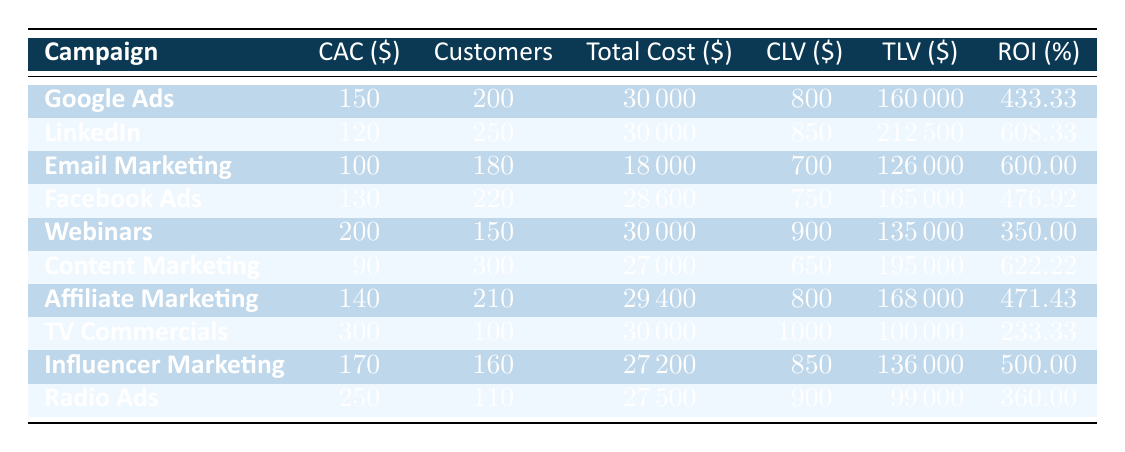What is the Cost of Customer Acquisition (CAC) for Email Marketing? The table shows that the CAC for the Email Marketing campaign is listed under the "CAC ($)" column. Looking at the row for Email Marketing, the value provided is 100.
Answer: 100 Which marketing campaign had the highest total lifetime value (TLV)? Upon examining the "TLV ($)" column, the highest value is found by comparing all campaigns. The LinkedIn Sponsored Content campaign has a TLV of 212,500, which is greater than all other campaigns.
Answer: LinkedIn Sponsored Content What is the average return on investment (ROI) across all marketing campaigns? To find the average ROI, I need to sum all the ROI percentages from each campaign and divide by the number of campaigns. The ROIs are 433.33, 608.33, 600.00, 476.92, 350.00, 622.22, 471.43, 233.33, 500.00, and 360.00. Summing these gives 4162.63, and dividing by 10 yields an average ROI of about 416.26.
Answer: 416.26 Did the Webinars campaign produce more customers than TV Commercials? Looking at the "Customers" column, Webinars acquired 150 customers while TV Commercials only acquired 100 customers. Therefore, Webinars did indeed produce more customers than TV Commercials.
Answer: Yes If the Content Marketing campaign had an additional cost of 5,000, would its new ROI still be greater than 600? The total cost for Content Marketing is currently 27,000, and it's acquiring 300 customers with a CLV of 650, giving a TLV of 195,000. The new total cost would be 27,000 + 5,000 = 32,000. The ROI would be calculated as (TLV - New Total Cost) / New Total Cost * 100, which is (195,000 - 32,000) / 32,000 * 100 = 509.38. This is less than 600.
Answer: No Which campaign had both the lowest CAC and the highest number of customers acquired? By analyzing both columns, Content Marketing has the lowest CAC at 90, and it also acquired 300 customers, which is the highest among all campaigns. Therefore, it fits both criteria.
Answer: Content Marketing Is the average customer lifetime value (CLV) higher for Radio Ads than it is for Webinars? For Radio Ads, the CLV is 900, and for Webinars, it is 900 as well. Therefore, they are equal, not higher for Radio Ads.
Answer: No How much did the Facebook Ads campaign cost overall, and what was the corresponding ROI? The total cost for Facebook Ads is 28,600, and its ROI is listed in the table as 476.92. Both figures are directly found in their respective columns.
Answer: 28,600; 476.92 